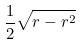Convert formula to latex. <formula><loc_0><loc_0><loc_500><loc_500>\frac { 1 } { 2 } \sqrt { r - r ^ { 2 } }</formula> 